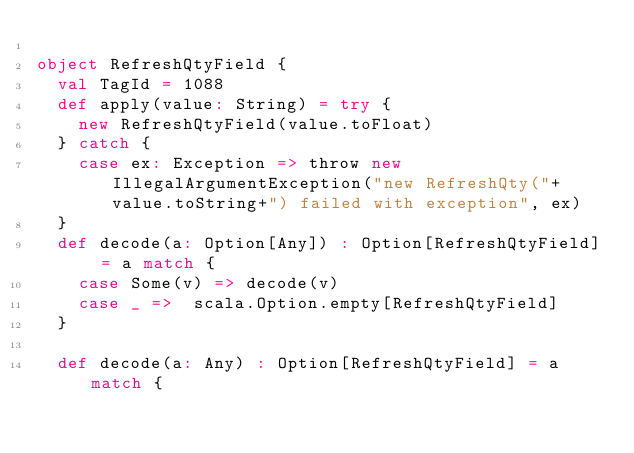<code> <loc_0><loc_0><loc_500><loc_500><_Scala_>
object RefreshQtyField {
  val TagId = 1088  
  def apply(value: String) = try {
    new RefreshQtyField(value.toFloat)
  } catch {
    case ex: Exception => throw new IllegalArgumentException("new RefreshQty("+value.toString+") failed with exception", ex)
  } 
  def decode(a: Option[Any]) : Option[RefreshQtyField] = a match {
    case Some(v) => decode(v)
    case _ =>  scala.Option.empty[RefreshQtyField]
  }

  def decode(a: Any) : Option[RefreshQtyField] = a match {</code> 